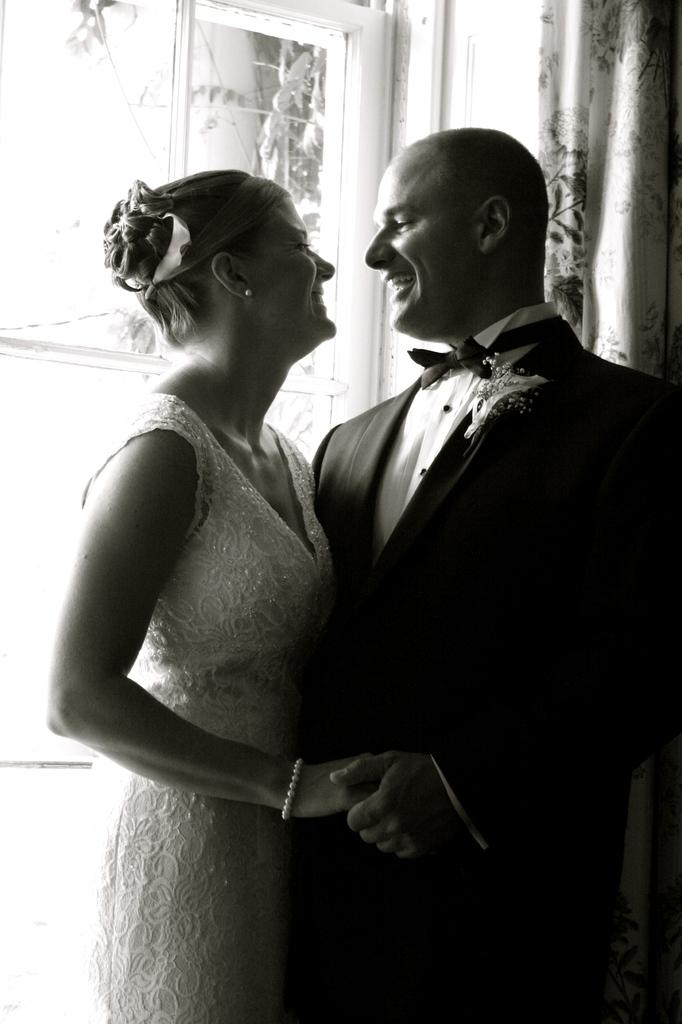Who is present in the image? There is a couple in the image. What are the couple doing in the image? The couple is hugging each other and laughing. What can be seen in the background of the image? There is a window in the background of the image. What is beside the window? There is a curtain beside the window. What type of bell can be heard ringing in the image? There is no bell present or ringing in the image. What kind of drug is the couple taking in the image? There is no drug present or being taken in the image. 